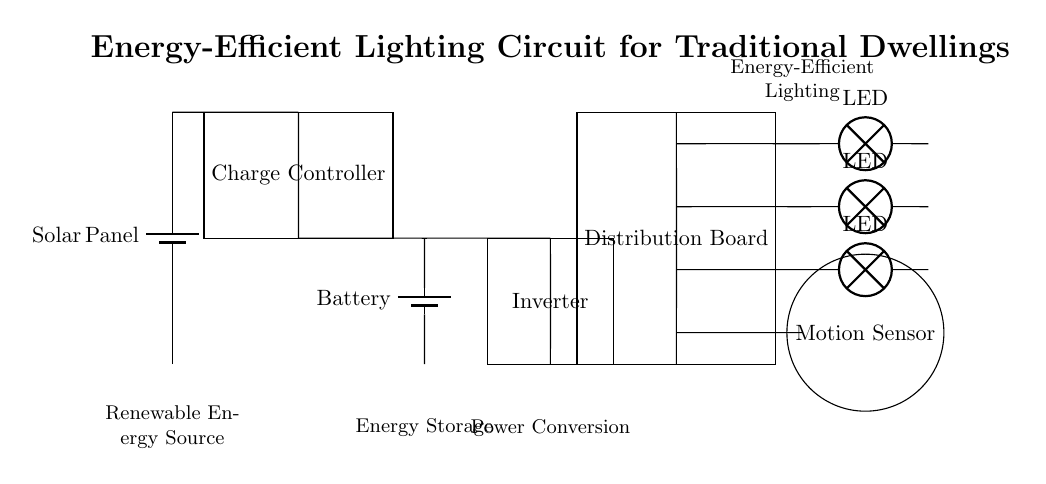What is the renewable energy source in this circuit? The renewable energy source in this circuit is a solar panel, which is indicated at the top of the circuit diagram.
Answer: Solar Panel What component is used for energy storage? The component used for energy storage in this circuit is a battery, shown at the lower part of the circuit.
Answer: Battery How many LED lights are included in the circuit? The circuit shows three LED lights connected in parallel, as represented in the circuit diagram.
Answer: Three What type of sensor is used in this circuit? The type of sensor used in this circuit is a motion sensor, which is depicted at the bottom of the diagram.
Answer: Motion Sensor What is the function of the charge controller? The function of the charge controller is to regulate the voltage and current coming from the solar panel to protect the battery from overcharging and ensure proper charging.
Answer: Voltage regulation What component converts DC to AC in this circuit? The component that converts direct current (DC) to alternating current (AC) in this circuit is the inverter, located adjacent to the battery.
Answer: Inverter What is the role of the distribution board in this circuit? The distribution board plays a crucial role in distributing electrical power to various circuits in the dwelling while protecting the circuit from overloads.
Answer: Power distribution 